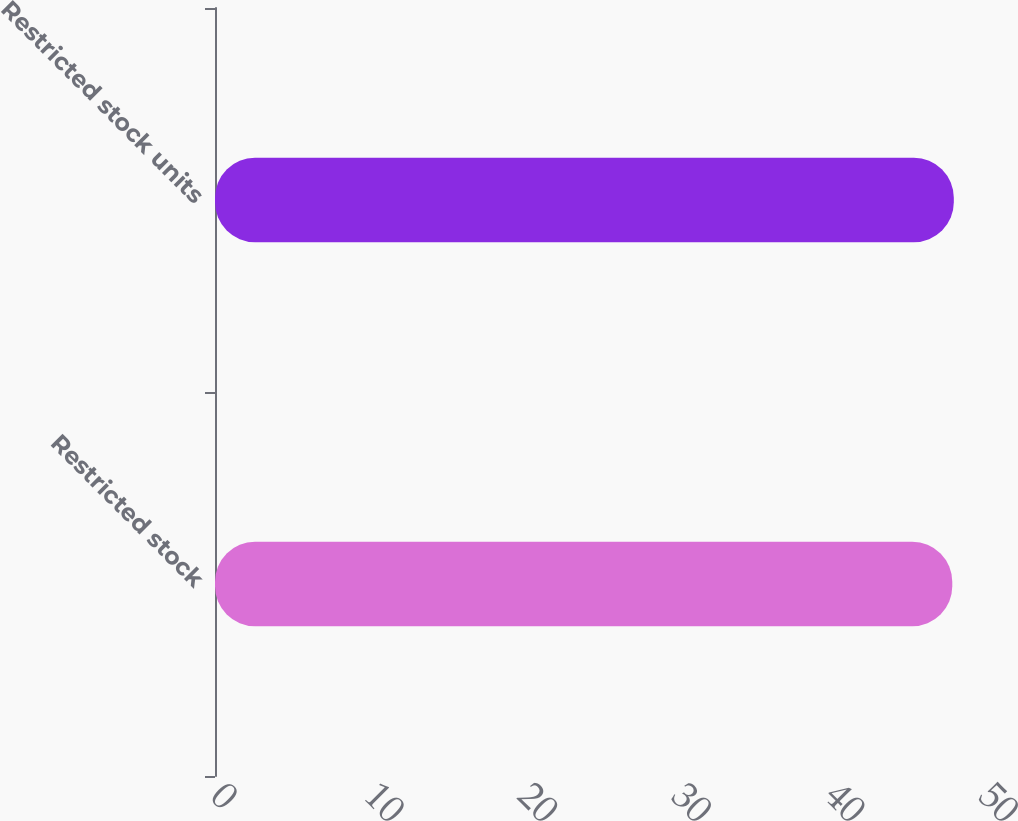Convert chart. <chart><loc_0><loc_0><loc_500><loc_500><bar_chart><fcel>Restricted stock<fcel>Restricted stock units<nl><fcel>48<fcel>48.1<nl></chart> 